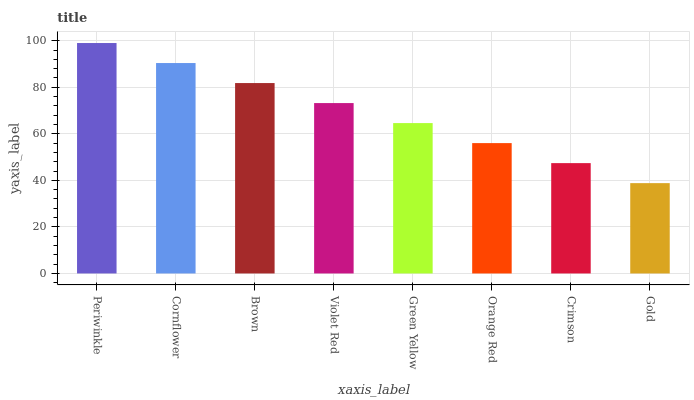Is Gold the minimum?
Answer yes or no. Yes. Is Periwinkle the maximum?
Answer yes or no. Yes. Is Cornflower the minimum?
Answer yes or no. No. Is Cornflower the maximum?
Answer yes or no. No. Is Periwinkle greater than Cornflower?
Answer yes or no. Yes. Is Cornflower less than Periwinkle?
Answer yes or no. Yes. Is Cornflower greater than Periwinkle?
Answer yes or no. No. Is Periwinkle less than Cornflower?
Answer yes or no. No. Is Violet Red the high median?
Answer yes or no. Yes. Is Green Yellow the low median?
Answer yes or no. Yes. Is Periwinkle the high median?
Answer yes or no. No. Is Periwinkle the low median?
Answer yes or no. No. 